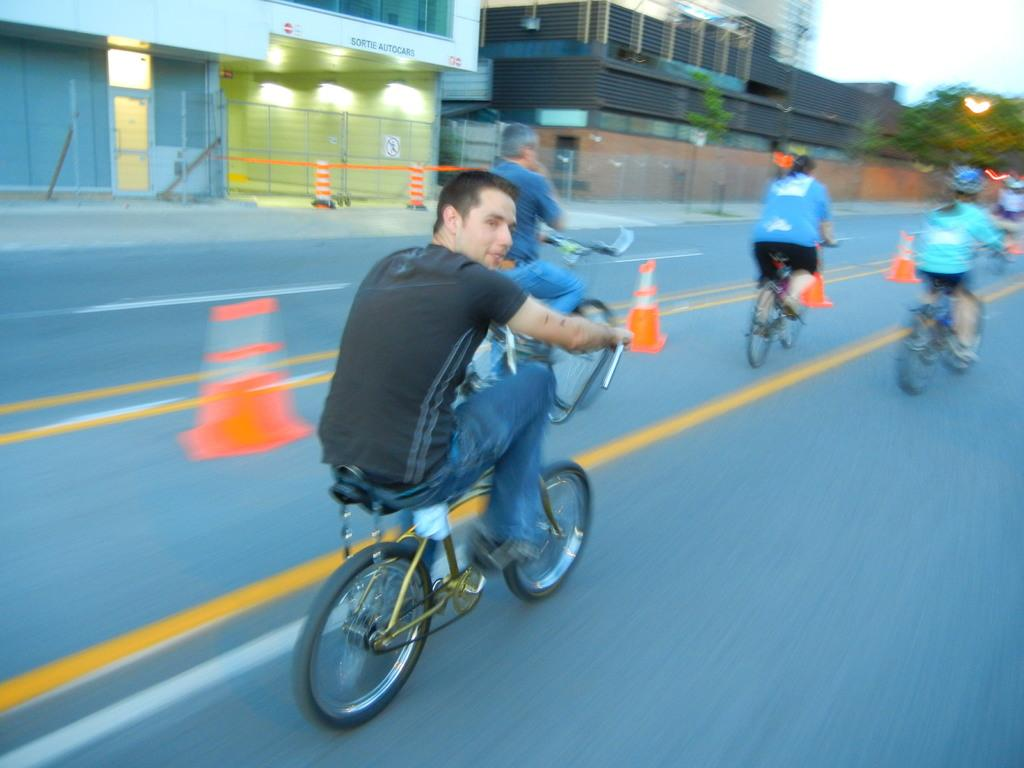What are the people in the image doing? The people in the image are riding bicycles on the road. What safety measures are present in the image? Traffic cones are present in the image. What type of structures can be seen in the image? There are buildings visible in the image. What type of lighting is present in the image? Lights are present in the image. What type of vegetation is visible in the image? Trees are visible in the image. What type of barrier is present in the image? Fences are present in the image. What other objects can be seen in the image? There are other objects in the image, but their specific details are not mentioned in the facts. What is visible in the background of the image? The sky is visible in the background of the image. What type of tin is being used to sing a song in the image? There is no tin or singing present in the image; it features people riding bicycles on the road. What type of crook is visible in the image? There is no crook present in the image; it features people riding bicycles on the road, traffic cones, buildings, lights, trees, fences, and the sky. 